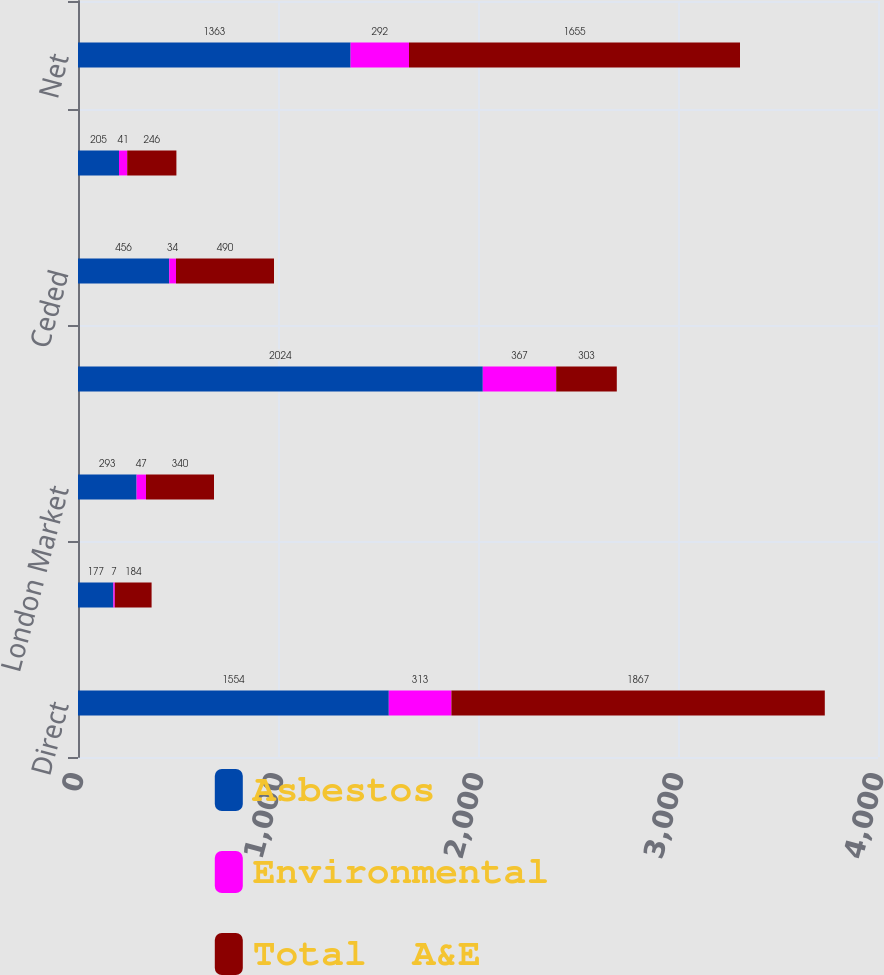<chart> <loc_0><loc_0><loc_500><loc_500><stacked_bar_chart><ecel><fcel>Direct<fcel>Assumed Reinsurance<fcel>London Market<fcel>Total<fcel>Ceded<fcel>Net reserves transferred to<fcel>Net<nl><fcel>Asbestos<fcel>1554<fcel>177<fcel>293<fcel>2024<fcel>456<fcel>205<fcel>1363<nl><fcel>Environmental<fcel>313<fcel>7<fcel>47<fcel>367<fcel>34<fcel>41<fcel>292<nl><fcel>Total  A&E<fcel>1867<fcel>184<fcel>340<fcel>303<fcel>490<fcel>246<fcel>1655<nl></chart> 